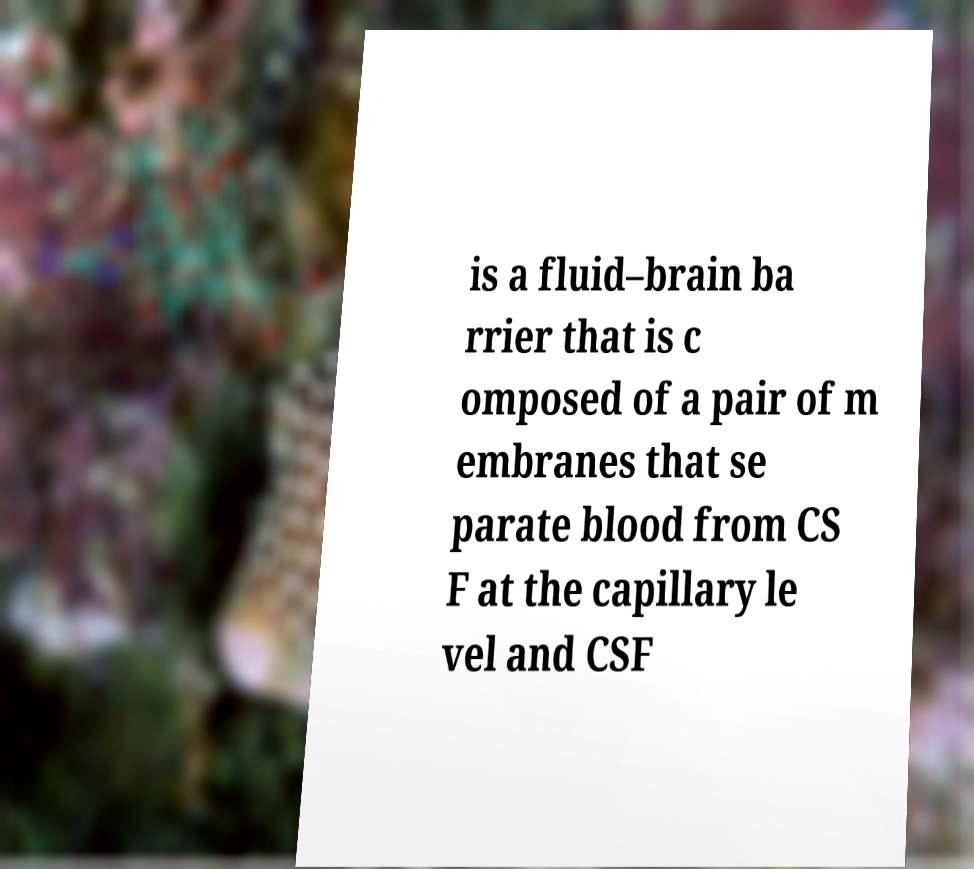Can you read and provide the text displayed in the image?This photo seems to have some interesting text. Can you extract and type it out for me? is a fluid–brain ba rrier that is c omposed of a pair of m embranes that se parate blood from CS F at the capillary le vel and CSF 